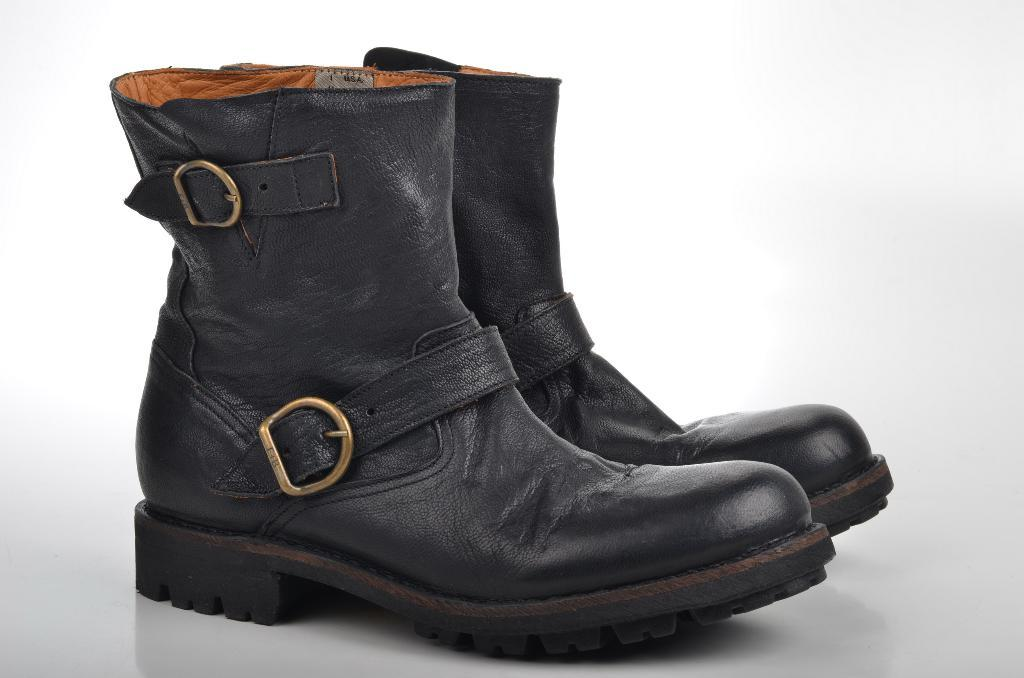What type of footwear is visible in the image? There are boots in the image. What color is the background of the image? The background of the image is white. How many houses are visible in the image? There are no houses visible in the image; it only features boots and a white background. What type of knot is tied on the boots in the image? There is no knot visible on the boots in the image. 